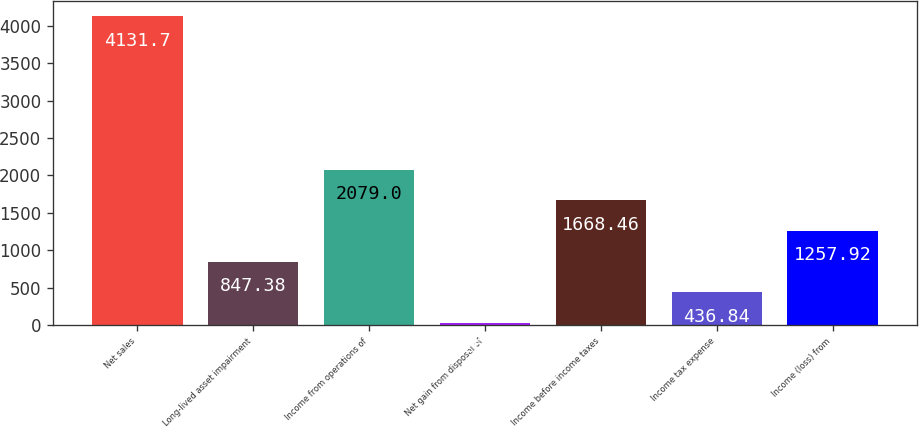Convert chart. <chart><loc_0><loc_0><loc_500><loc_500><bar_chart><fcel>Net sales<fcel>Long-lived asset impairment<fcel>Income from operations of<fcel>Net gain from disposal of<fcel>Income before income taxes<fcel>Income tax expense<fcel>Income (loss) from<nl><fcel>4131.7<fcel>847.38<fcel>2079<fcel>26.3<fcel>1668.46<fcel>436.84<fcel>1257.92<nl></chart> 